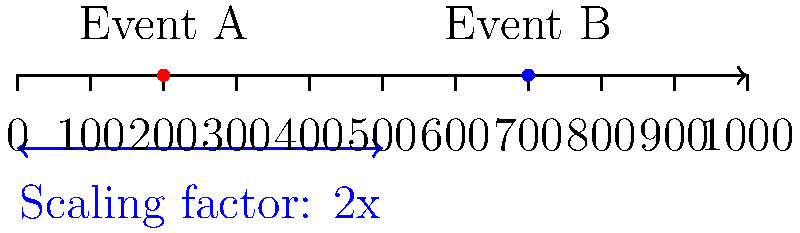In the historical timeline diagram above, events A and B are placed on a scale where each unit represents 100 years. If we want to create a new timeline where each unit represents 50 years instead, what would be the scaling factor to accurately reposition events A and B on the new timeline? To solve this problem, let's follow these steps:

1. Understand the current scale:
   - Each unit on the current timeline represents 100 years.
   - Event A is at position 2, which means it occurred 200 years after the start.
   - Event B is at position 7, which means it occurred 700 years after the start.

2. Understand the desired new scale:
   - We want each unit to represent 50 years instead of 100 years.

3. Calculate the scaling factor:
   - To go from 100 years per unit to 50 years per unit, we need to double the number of units for the same time period.
   - This means we need to stretch the timeline by a factor of 2.

4. Verify the scaling:
   - Event A: 200 years ÷ 50 years/unit = 4 units on the new scale
   - Event B: 700 years ÷ 50 years/unit = 14 units on the new scale

5. Express the scaling mathematically:
   - The scaling factor can be represented as $\frac{\text{new scale}}{\text{old scale}} = \frac{50 \text{ years/unit}}{100 \text{ years/unit}} = \frac{1}{2}$
   - To find the new position, we multiply by the reciprocal: $2 = \frac{2}{1}$

Therefore, to accurately reposition events A and B on the new timeline, we need to multiply their current positions by a scaling factor of 2.
Answer: 2 